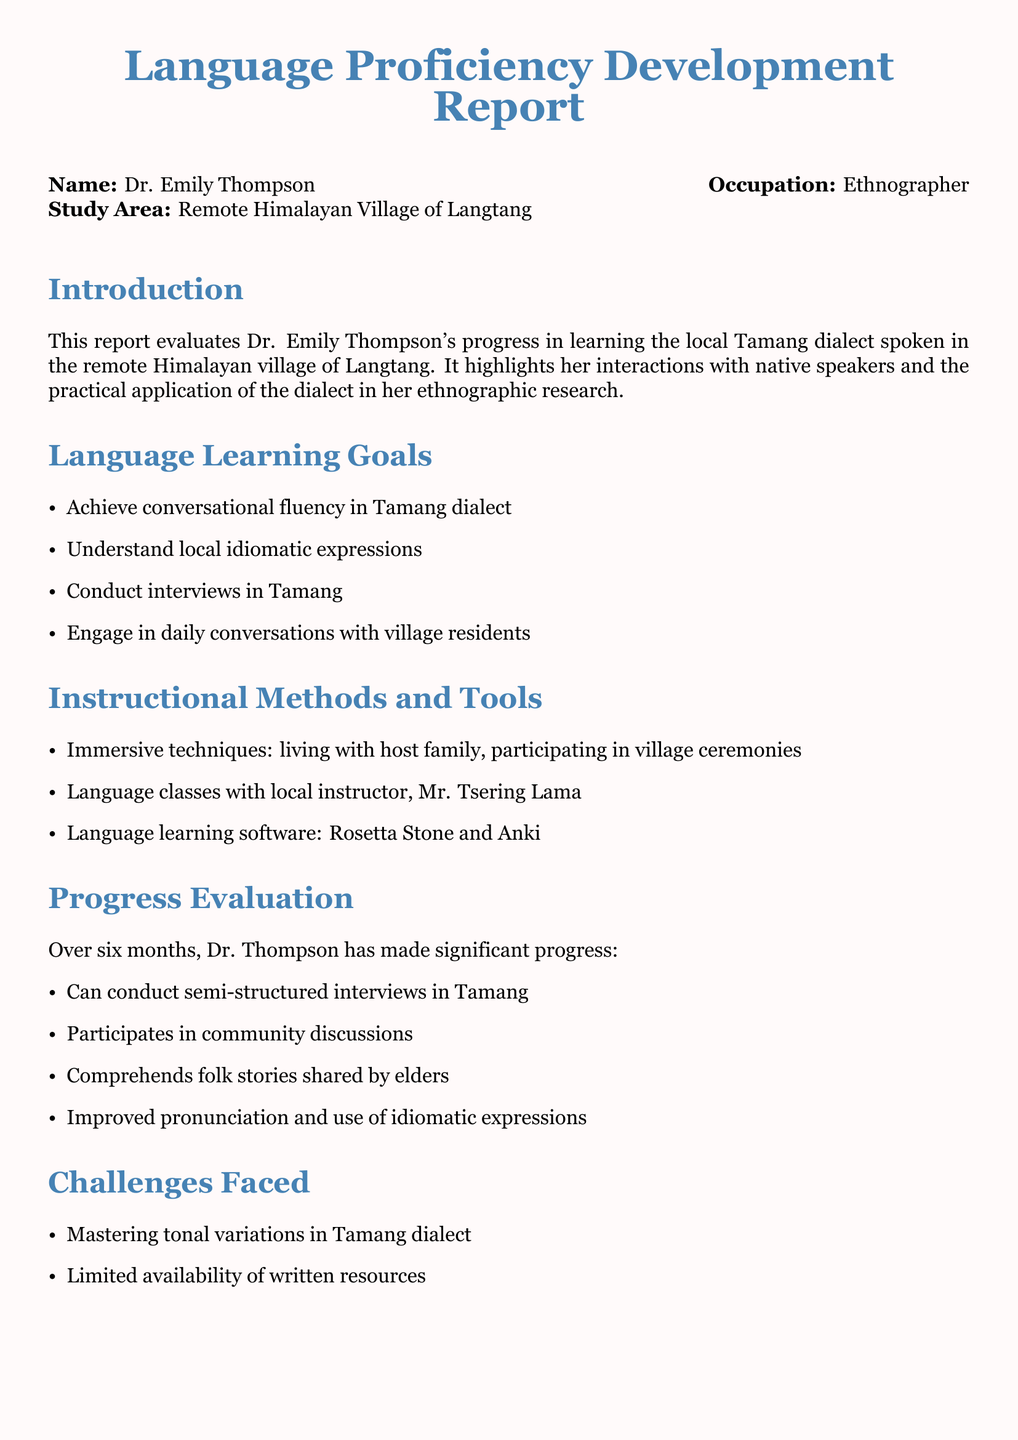What is the name of the ethnographer? The name listed in the document is Dr. Emily Thompson.
Answer: Dr. Emily Thompson What is the study area mentioned in the report? The report states that the study area is the Remote Himalayan Village of Langtang.
Answer: Remote Himalayan Village of Langtang Who is the local instructor mentioned? The document mentions Mr. Tsering Lama as the local instructor.
Answer: Mr. Tsering Lama What is one of the language learning goals? The document lists several goals, one being to achieve conversational fluency in Tamang dialect.
Answer: Achieve conversational fluency in Tamang dialect What challenge is noted in mastering the dialect? The report states that mastering tonal variations in the Tamang dialect is a challenge faced.
Answer: Tonal variations How long did the progress evaluation take place? The text indicates that the progress was evaluated over six months.
Answer: Six months What is one of the future plans Dr. Thompson has? The document states that one future plan includes documenting oral histories.
Answer: Documenting oral histories What kind of interviews can Dr. Thompson conduct now? The report mentions she can conduct semi-structured interviews in Tamang.
Answer: Semi-structured interviews What is a recommendation for continuing language practice? The document recommends continuing to participate in communal activities.
Answer: Participate in communal activities 